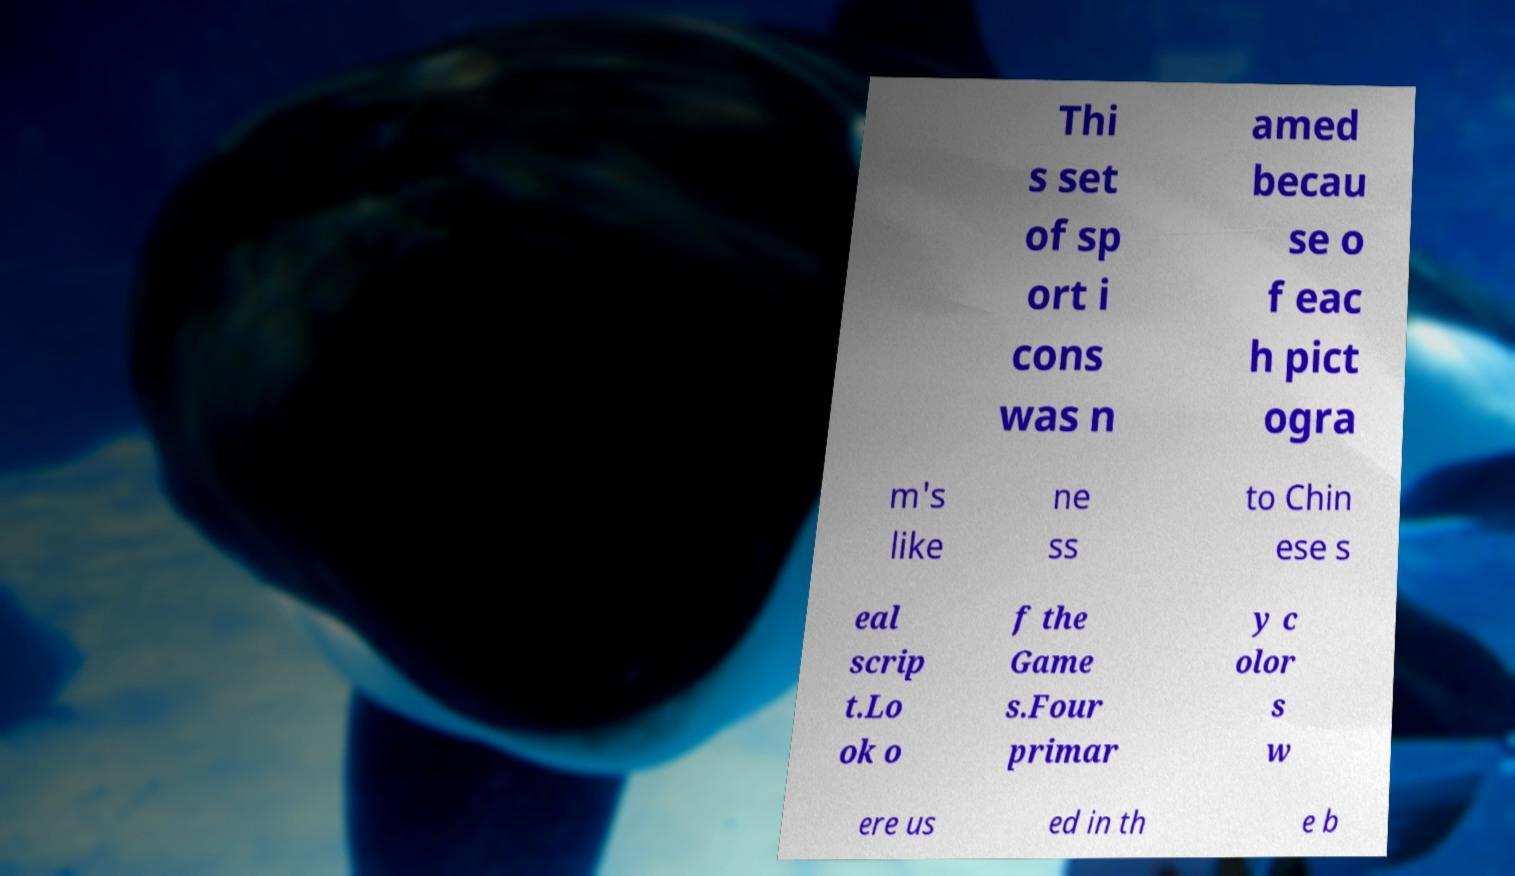I need the written content from this picture converted into text. Can you do that? Thi s set of sp ort i cons was n amed becau se o f eac h pict ogra m's like ne ss to Chin ese s eal scrip t.Lo ok o f the Game s.Four primar y c olor s w ere us ed in th e b 